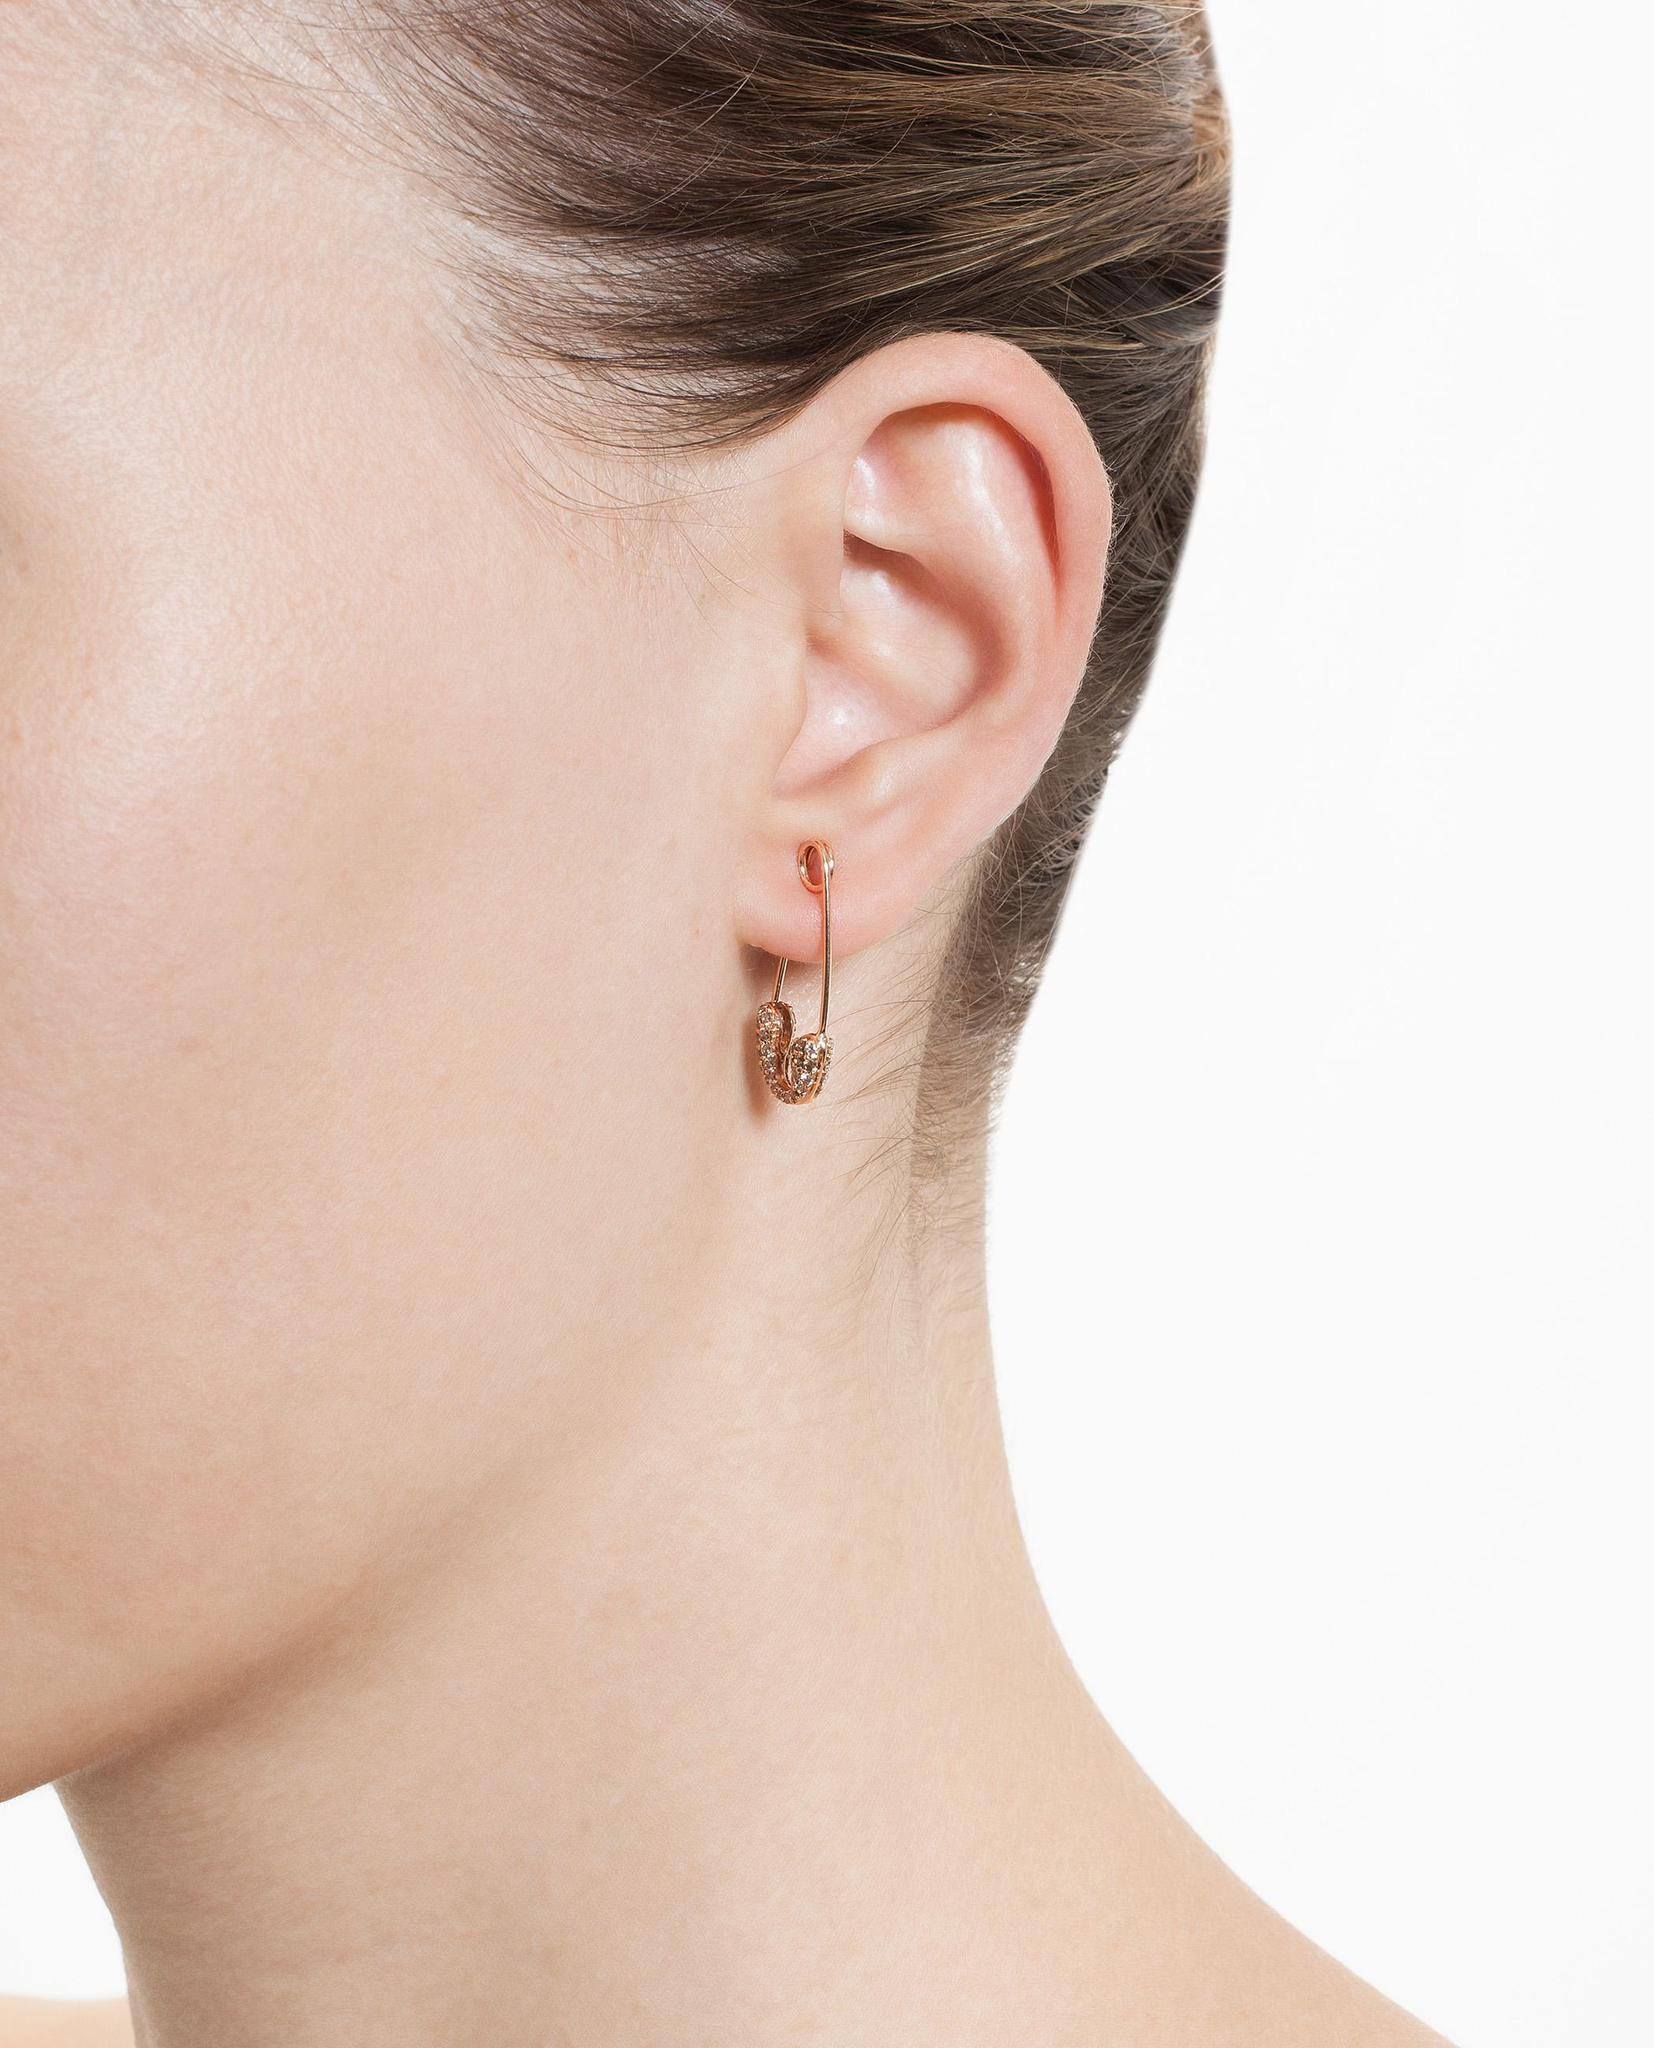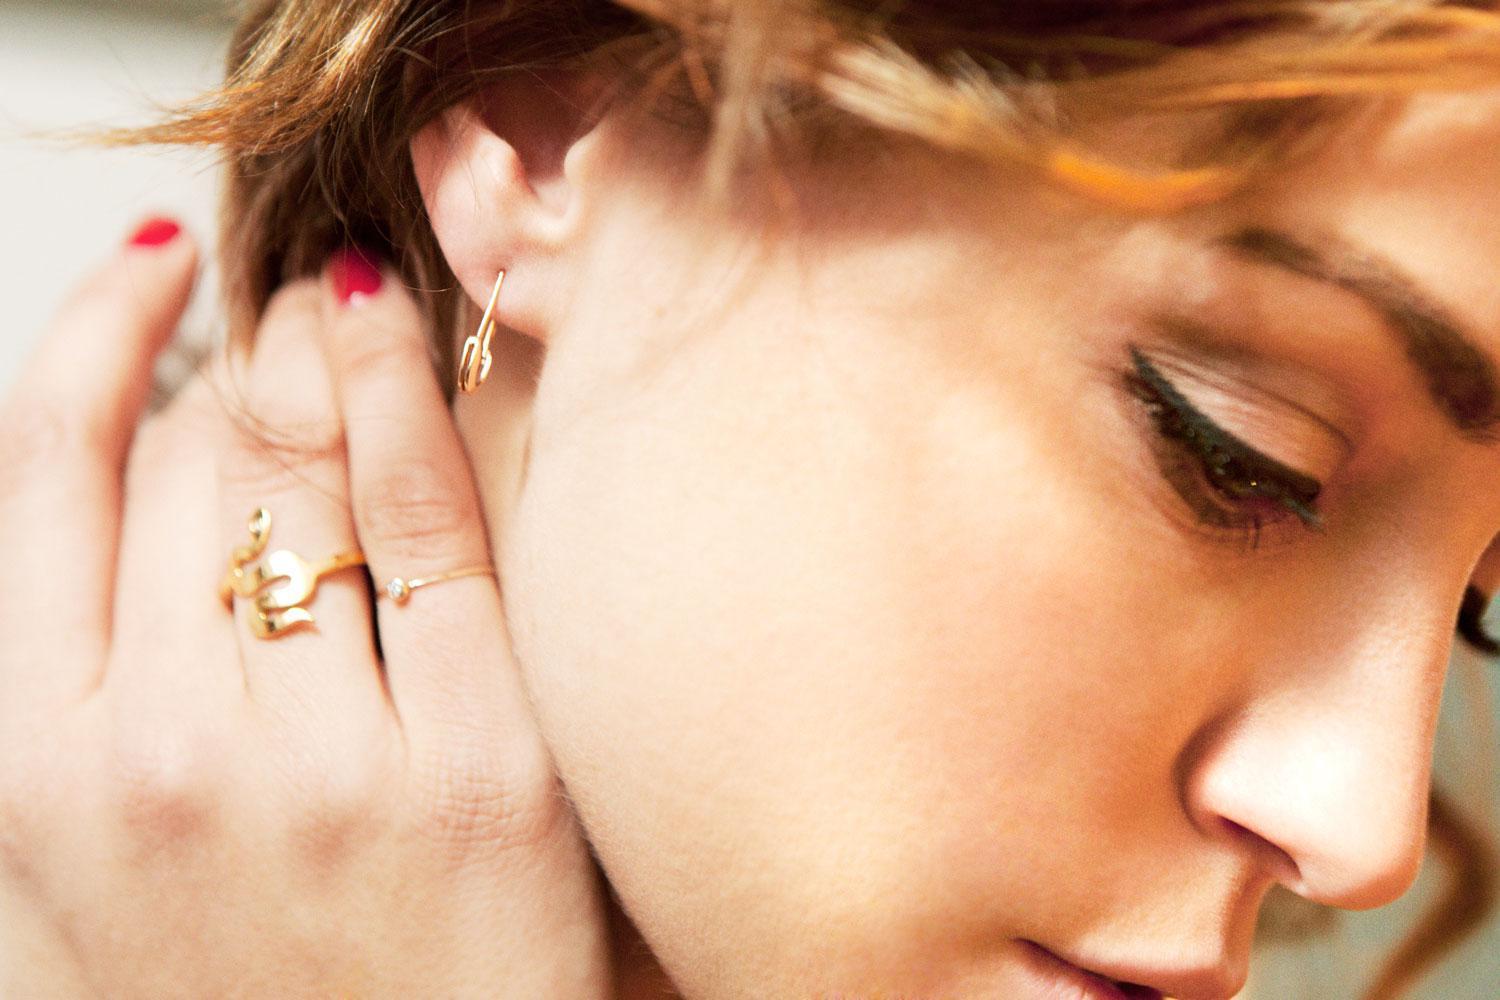The first image is the image on the left, the second image is the image on the right. Evaluate the accuracy of this statement regarding the images: "One of the images shows a safety pin that is in a location other than a woman's ear.". Is it true? Answer yes or no. No. The first image is the image on the left, the second image is the image on the right. Assess this claim about the two images: "There are two women who are both wearing earrings.". Correct or not? Answer yes or no. Yes. 